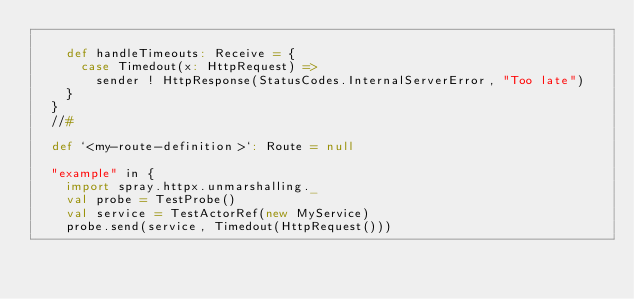Convert code to text. <code><loc_0><loc_0><loc_500><loc_500><_Scala_>
    def handleTimeouts: Receive = {
      case Timedout(x: HttpRequest) =>
        sender ! HttpResponse(StatusCodes.InternalServerError, "Too late")
    }
  }
  //#

  def `<my-route-definition>`: Route = null

  "example" in {
    import spray.httpx.unmarshalling._
    val probe = TestProbe()
    val service = TestActorRef(new MyService)
    probe.send(service, Timedout(HttpRequest()))</code> 